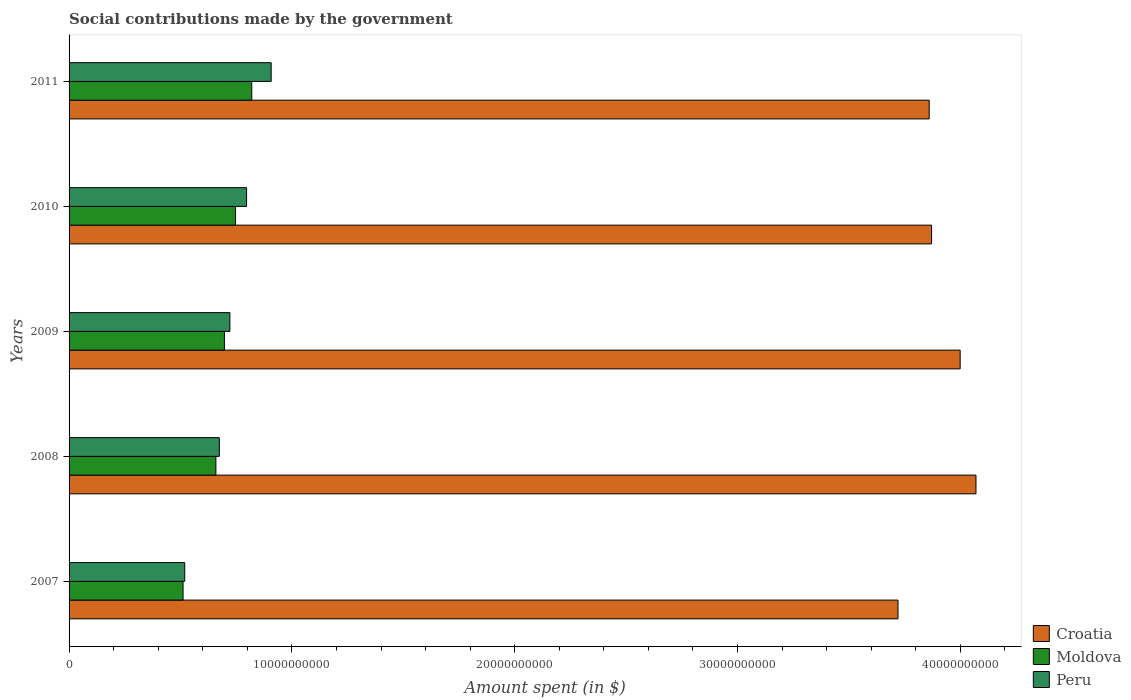How many groups of bars are there?
Make the answer very short. 5. How many bars are there on the 4th tick from the bottom?
Keep it short and to the point. 3. What is the amount spent on social contributions in Peru in 2011?
Make the answer very short. 9.07e+09. Across all years, what is the maximum amount spent on social contributions in Croatia?
Ensure brevity in your answer.  4.07e+1. Across all years, what is the minimum amount spent on social contributions in Moldova?
Your answer should be compact. 5.12e+09. In which year was the amount spent on social contributions in Croatia minimum?
Ensure brevity in your answer.  2007. What is the total amount spent on social contributions in Peru in the graph?
Ensure brevity in your answer.  3.62e+1. What is the difference between the amount spent on social contributions in Moldova in 2009 and that in 2011?
Provide a succinct answer. -1.23e+09. What is the difference between the amount spent on social contributions in Peru in 2009 and the amount spent on social contributions in Moldova in 2011?
Ensure brevity in your answer.  -9.81e+08. What is the average amount spent on social contributions in Croatia per year?
Provide a short and direct response. 3.90e+1. In the year 2007, what is the difference between the amount spent on social contributions in Moldova and amount spent on social contributions in Croatia?
Keep it short and to the point. -3.21e+1. In how many years, is the amount spent on social contributions in Croatia greater than 34000000000 $?
Give a very brief answer. 5. What is the ratio of the amount spent on social contributions in Peru in 2008 to that in 2010?
Offer a very short reply. 0.85. Is the difference between the amount spent on social contributions in Moldova in 2007 and 2010 greater than the difference between the amount spent on social contributions in Croatia in 2007 and 2010?
Ensure brevity in your answer.  No. What is the difference between the highest and the second highest amount spent on social contributions in Moldova?
Your answer should be compact. 7.27e+08. What is the difference between the highest and the lowest amount spent on social contributions in Peru?
Provide a succinct answer. 3.88e+09. Is the sum of the amount spent on social contributions in Peru in 2009 and 2010 greater than the maximum amount spent on social contributions in Moldova across all years?
Keep it short and to the point. Yes. What does the 2nd bar from the bottom in 2010 represents?
Your response must be concise. Moldova. Is it the case that in every year, the sum of the amount spent on social contributions in Croatia and amount spent on social contributions in Moldova is greater than the amount spent on social contributions in Peru?
Provide a short and direct response. Yes. How many bars are there?
Provide a succinct answer. 15. Does the graph contain any zero values?
Make the answer very short. No. How are the legend labels stacked?
Offer a terse response. Vertical. What is the title of the graph?
Keep it short and to the point. Social contributions made by the government. What is the label or title of the X-axis?
Make the answer very short. Amount spent (in $). What is the label or title of the Y-axis?
Offer a very short reply. Years. What is the Amount spent (in $) in Croatia in 2007?
Your answer should be compact. 3.72e+1. What is the Amount spent (in $) of Moldova in 2007?
Your response must be concise. 5.12e+09. What is the Amount spent (in $) of Peru in 2007?
Give a very brief answer. 5.19e+09. What is the Amount spent (in $) of Croatia in 2008?
Make the answer very short. 4.07e+1. What is the Amount spent (in $) of Moldova in 2008?
Keep it short and to the point. 6.59e+09. What is the Amount spent (in $) of Peru in 2008?
Your answer should be compact. 6.74e+09. What is the Amount spent (in $) of Croatia in 2009?
Give a very brief answer. 4.00e+1. What is the Amount spent (in $) of Moldova in 2009?
Provide a succinct answer. 6.97e+09. What is the Amount spent (in $) of Peru in 2009?
Provide a succinct answer. 7.22e+09. What is the Amount spent (in $) in Croatia in 2010?
Your answer should be very brief. 3.87e+1. What is the Amount spent (in $) in Moldova in 2010?
Ensure brevity in your answer.  7.47e+09. What is the Amount spent (in $) of Peru in 2010?
Give a very brief answer. 7.97e+09. What is the Amount spent (in $) of Croatia in 2011?
Make the answer very short. 3.86e+1. What is the Amount spent (in $) of Moldova in 2011?
Make the answer very short. 8.20e+09. What is the Amount spent (in $) of Peru in 2011?
Make the answer very short. 9.07e+09. Across all years, what is the maximum Amount spent (in $) in Croatia?
Your answer should be very brief. 4.07e+1. Across all years, what is the maximum Amount spent (in $) in Moldova?
Ensure brevity in your answer.  8.20e+09. Across all years, what is the maximum Amount spent (in $) in Peru?
Your response must be concise. 9.07e+09. Across all years, what is the minimum Amount spent (in $) of Croatia?
Give a very brief answer. 3.72e+1. Across all years, what is the minimum Amount spent (in $) in Moldova?
Provide a short and direct response. 5.12e+09. Across all years, what is the minimum Amount spent (in $) in Peru?
Give a very brief answer. 5.19e+09. What is the total Amount spent (in $) of Croatia in the graph?
Keep it short and to the point. 1.95e+11. What is the total Amount spent (in $) of Moldova in the graph?
Your response must be concise. 3.43e+1. What is the total Amount spent (in $) in Peru in the graph?
Your response must be concise. 3.62e+1. What is the difference between the Amount spent (in $) of Croatia in 2007 and that in 2008?
Offer a very short reply. -3.50e+09. What is the difference between the Amount spent (in $) of Moldova in 2007 and that in 2008?
Your response must be concise. -1.47e+09. What is the difference between the Amount spent (in $) of Peru in 2007 and that in 2008?
Your response must be concise. -1.55e+09. What is the difference between the Amount spent (in $) in Croatia in 2007 and that in 2009?
Give a very brief answer. -2.79e+09. What is the difference between the Amount spent (in $) in Moldova in 2007 and that in 2009?
Your answer should be very brief. -1.86e+09. What is the difference between the Amount spent (in $) in Peru in 2007 and that in 2009?
Provide a short and direct response. -2.03e+09. What is the difference between the Amount spent (in $) of Croatia in 2007 and that in 2010?
Your answer should be compact. -1.51e+09. What is the difference between the Amount spent (in $) of Moldova in 2007 and that in 2010?
Provide a succinct answer. -2.36e+09. What is the difference between the Amount spent (in $) in Peru in 2007 and that in 2010?
Offer a very short reply. -2.78e+09. What is the difference between the Amount spent (in $) of Croatia in 2007 and that in 2011?
Give a very brief answer. -1.40e+09. What is the difference between the Amount spent (in $) of Moldova in 2007 and that in 2011?
Your answer should be very brief. -3.08e+09. What is the difference between the Amount spent (in $) of Peru in 2007 and that in 2011?
Offer a terse response. -3.88e+09. What is the difference between the Amount spent (in $) of Croatia in 2008 and that in 2009?
Offer a terse response. 7.09e+08. What is the difference between the Amount spent (in $) of Moldova in 2008 and that in 2009?
Make the answer very short. -3.82e+08. What is the difference between the Amount spent (in $) in Peru in 2008 and that in 2009?
Provide a short and direct response. -4.73e+08. What is the difference between the Amount spent (in $) in Croatia in 2008 and that in 2010?
Your answer should be compact. 1.99e+09. What is the difference between the Amount spent (in $) of Moldova in 2008 and that in 2010?
Keep it short and to the point. -8.82e+08. What is the difference between the Amount spent (in $) in Peru in 2008 and that in 2010?
Provide a short and direct response. -1.22e+09. What is the difference between the Amount spent (in $) of Croatia in 2008 and that in 2011?
Ensure brevity in your answer.  2.10e+09. What is the difference between the Amount spent (in $) of Moldova in 2008 and that in 2011?
Offer a very short reply. -1.61e+09. What is the difference between the Amount spent (in $) of Peru in 2008 and that in 2011?
Provide a succinct answer. -2.33e+09. What is the difference between the Amount spent (in $) in Croatia in 2009 and that in 2010?
Provide a short and direct response. 1.28e+09. What is the difference between the Amount spent (in $) in Moldova in 2009 and that in 2010?
Ensure brevity in your answer.  -5.00e+08. What is the difference between the Amount spent (in $) of Peru in 2009 and that in 2010?
Provide a short and direct response. -7.49e+08. What is the difference between the Amount spent (in $) in Croatia in 2009 and that in 2011?
Make the answer very short. 1.39e+09. What is the difference between the Amount spent (in $) of Moldova in 2009 and that in 2011?
Give a very brief answer. -1.23e+09. What is the difference between the Amount spent (in $) of Peru in 2009 and that in 2011?
Your answer should be compact. -1.85e+09. What is the difference between the Amount spent (in $) in Croatia in 2010 and that in 2011?
Ensure brevity in your answer.  1.07e+08. What is the difference between the Amount spent (in $) of Moldova in 2010 and that in 2011?
Provide a short and direct response. -7.27e+08. What is the difference between the Amount spent (in $) of Peru in 2010 and that in 2011?
Your response must be concise. -1.10e+09. What is the difference between the Amount spent (in $) in Croatia in 2007 and the Amount spent (in $) in Moldova in 2008?
Provide a short and direct response. 3.06e+1. What is the difference between the Amount spent (in $) in Croatia in 2007 and the Amount spent (in $) in Peru in 2008?
Offer a very short reply. 3.05e+1. What is the difference between the Amount spent (in $) in Moldova in 2007 and the Amount spent (in $) in Peru in 2008?
Keep it short and to the point. -1.63e+09. What is the difference between the Amount spent (in $) of Croatia in 2007 and the Amount spent (in $) of Moldova in 2009?
Keep it short and to the point. 3.02e+1. What is the difference between the Amount spent (in $) of Croatia in 2007 and the Amount spent (in $) of Peru in 2009?
Give a very brief answer. 3.00e+1. What is the difference between the Amount spent (in $) of Moldova in 2007 and the Amount spent (in $) of Peru in 2009?
Your response must be concise. -2.10e+09. What is the difference between the Amount spent (in $) of Croatia in 2007 and the Amount spent (in $) of Moldova in 2010?
Provide a short and direct response. 2.97e+1. What is the difference between the Amount spent (in $) in Croatia in 2007 and the Amount spent (in $) in Peru in 2010?
Provide a succinct answer. 2.92e+1. What is the difference between the Amount spent (in $) of Moldova in 2007 and the Amount spent (in $) of Peru in 2010?
Your response must be concise. -2.85e+09. What is the difference between the Amount spent (in $) in Croatia in 2007 and the Amount spent (in $) in Moldova in 2011?
Keep it short and to the point. 2.90e+1. What is the difference between the Amount spent (in $) in Croatia in 2007 and the Amount spent (in $) in Peru in 2011?
Provide a short and direct response. 2.81e+1. What is the difference between the Amount spent (in $) of Moldova in 2007 and the Amount spent (in $) of Peru in 2011?
Give a very brief answer. -3.95e+09. What is the difference between the Amount spent (in $) of Croatia in 2008 and the Amount spent (in $) of Moldova in 2009?
Offer a very short reply. 3.37e+1. What is the difference between the Amount spent (in $) of Croatia in 2008 and the Amount spent (in $) of Peru in 2009?
Offer a terse response. 3.35e+1. What is the difference between the Amount spent (in $) of Moldova in 2008 and the Amount spent (in $) of Peru in 2009?
Give a very brief answer. -6.28e+08. What is the difference between the Amount spent (in $) of Croatia in 2008 and the Amount spent (in $) of Moldova in 2010?
Keep it short and to the point. 3.32e+1. What is the difference between the Amount spent (in $) in Croatia in 2008 and the Amount spent (in $) in Peru in 2010?
Offer a very short reply. 3.27e+1. What is the difference between the Amount spent (in $) of Moldova in 2008 and the Amount spent (in $) of Peru in 2010?
Offer a very short reply. -1.38e+09. What is the difference between the Amount spent (in $) in Croatia in 2008 and the Amount spent (in $) in Moldova in 2011?
Provide a short and direct response. 3.25e+1. What is the difference between the Amount spent (in $) in Croatia in 2008 and the Amount spent (in $) in Peru in 2011?
Give a very brief answer. 3.16e+1. What is the difference between the Amount spent (in $) of Moldova in 2008 and the Amount spent (in $) of Peru in 2011?
Ensure brevity in your answer.  -2.48e+09. What is the difference between the Amount spent (in $) in Croatia in 2009 and the Amount spent (in $) in Moldova in 2010?
Offer a very short reply. 3.25e+1. What is the difference between the Amount spent (in $) in Croatia in 2009 and the Amount spent (in $) in Peru in 2010?
Keep it short and to the point. 3.20e+1. What is the difference between the Amount spent (in $) in Moldova in 2009 and the Amount spent (in $) in Peru in 2010?
Your response must be concise. -9.95e+08. What is the difference between the Amount spent (in $) of Croatia in 2009 and the Amount spent (in $) of Moldova in 2011?
Your answer should be compact. 3.18e+1. What is the difference between the Amount spent (in $) in Croatia in 2009 and the Amount spent (in $) in Peru in 2011?
Your answer should be very brief. 3.09e+1. What is the difference between the Amount spent (in $) of Moldova in 2009 and the Amount spent (in $) of Peru in 2011?
Your response must be concise. -2.10e+09. What is the difference between the Amount spent (in $) in Croatia in 2010 and the Amount spent (in $) in Moldova in 2011?
Your answer should be compact. 3.05e+1. What is the difference between the Amount spent (in $) of Croatia in 2010 and the Amount spent (in $) of Peru in 2011?
Keep it short and to the point. 2.96e+1. What is the difference between the Amount spent (in $) in Moldova in 2010 and the Amount spent (in $) in Peru in 2011?
Offer a very short reply. -1.60e+09. What is the average Amount spent (in $) in Croatia per year?
Your answer should be compact. 3.90e+1. What is the average Amount spent (in $) in Moldova per year?
Provide a short and direct response. 6.87e+09. What is the average Amount spent (in $) of Peru per year?
Give a very brief answer. 7.24e+09. In the year 2007, what is the difference between the Amount spent (in $) of Croatia and Amount spent (in $) of Moldova?
Your answer should be very brief. 3.21e+1. In the year 2007, what is the difference between the Amount spent (in $) in Croatia and Amount spent (in $) in Peru?
Give a very brief answer. 3.20e+1. In the year 2007, what is the difference between the Amount spent (in $) of Moldova and Amount spent (in $) of Peru?
Provide a short and direct response. -7.49e+07. In the year 2008, what is the difference between the Amount spent (in $) in Croatia and Amount spent (in $) in Moldova?
Offer a very short reply. 3.41e+1. In the year 2008, what is the difference between the Amount spent (in $) of Croatia and Amount spent (in $) of Peru?
Keep it short and to the point. 3.40e+1. In the year 2008, what is the difference between the Amount spent (in $) in Moldova and Amount spent (in $) in Peru?
Your answer should be compact. -1.54e+08. In the year 2009, what is the difference between the Amount spent (in $) of Croatia and Amount spent (in $) of Moldova?
Ensure brevity in your answer.  3.30e+1. In the year 2009, what is the difference between the Amount spent (in $) of Croatia and Amount spent (in $) of Peru?
Your answer should be very brief. 3.28e+1. In the year 2009, what is the difference between the Amount spent (in $) in Moldova and Amount spent (in $) in Peru?
Ensure brevity in your answer.  -2.46e+08. In the year 2010, what is the difference between the Amount spent (in $) of Croatia and Amount spent (in $) of Moldova?
Make the answer very short. 3.12e+1. In the year 2010, what is the difference between the Amount spent (in $) of Croatia and Amount spent (in $) of Peru?
Your answer should be compact. 3.07e+1. In the year 2010, what is the difference between the Amount spent (in $) of Moldova and Amount spent (in $) of Peru?
Your answer should be compact. -4.95e+08. In the year 2011, what is the difference between the Amount spent (in $) in Croatia and Amount spent (in $) in Moldova?
Your answer should be very brief. 3.04e+1. In the year 2011, what is the difference between the Amount spent (in $) in Croatia and Amount spent (in $) in Peru?
Give a very brief answer. 2.95e+1. In the year 2011, what is the difference between the Amount spent (in $) in Moldova and Amount spent (in $) in Peru?
Offer a very short reply. -8.72e+08. What is the ratio of the Amount spent (in $) of Croatia in 2007 to that in 2008?
Your answer should be very brief. 0.91. What is the ratio of the Amount spent (in $) in Moldova in 2007 to that in 2008?
Provide a short and direct response. 0.78. What is the ratio of the Amount spent (in $) of Peru in 2007 to that in 2008?
Your answer should be very brief. 0.77. What is the ratio of the Amount spent (in $) of Croatia in 2007 to that in 2009?
Keep it short and to the point. 0.93. What is the ratio of the Amount spent (in $) in Moldova in 2007 to that in 2009?
Ensure brevity in your answer.  0.73. What is the ratio of the Amount spent (in $) of Peru in 2007 to that in 2009?
Make the answer very short. 0.72. What is the ratio of the Amount spent (in $) of Moldova in 2007 to that in 2010?
Your answer should be compact. 0.68. What is the ratio of the Amount spent (in $) in Peru in 2007 to that in 2010?
Give a very brief answer. 0.65. What is the ratio of the Amount spent (in $) of Croatia in 2007 to that in 2011?
Keep it short and to the point. 0.96. What is the ratio of the Amount spent (in $) of Moldova in 2007 to that in 2011?
Provide a short and direct response. 0.62. What is the ratio of the Amount spent (in $) of Peru in 2007 to that in 2011?
Make the answer very short. 0.57. What is the ratio of the Amount spent (in $) in Croatia in 2008 to that in 2009?
Provide a short and direct response. 1.02. What is the ratio of the Amount spent (in $) in Moldova in 2008 to that in 2009?
Keep it short and to the point. 0.95. What is the ratio of the Amount spent (in $) in Peru in 2008 to that in 2009?
Ensure brevity in your answer.  0.93. What is the ratio of the Amount spent (in $) in Croatia in 2008 to that in 2010?
Give a very brief answer. 1.05. What is the ratio of the Amount spent (in $) in Moldova in 2008 to that in 2010?
Your answer should be very brief. 0.88. What is the ratio of the Amount spent (in $) in Peru in 2008 to that in 2010?
Provide a short and direct response. 0.85. What is the ratio of the Amount spent (in $) of Croatia in 2008 to that in 2011?
Ensure brevity in your answer.  1.05. What is the ratio of the Amount spent (in $) in Moldova in 2008 to that in 2011?
Make the answer very short. 0.8. What is the ratio of the Amount spent (in $) of Peru in 2008 to that in 2011?
Provide a short and direct response. 0.74. What is the ratio of the Amount spent (in $) in Croatia in 2009 to that in 2010?
Provide a short and direct response. 1.03. What is the ratio of the Amount spent (in $) in Moldova in 2009 to that in 2010?
Your response must be concise. 0.93. What is the ratio of the Amount spent (in $) in Peru in 2009 to that in 2010?
Provide a succinct answer. 0.91. What is the ratio of the Amount spent (in $) of Croatia in 2009 to that in 2011?
Make the answer very short. 1.04. What is the ratio of the Amount spent (in $) in Moldova in 2009 to that in 2011?
Your answer should be compact. 0.85. What is the ratio of the Amount spent (in $) in Peru in 2009 to that in 2011?
Offer a terse response. 0.8. What is the ratio of the Amount spent (in $) of Croatia in 2010 to that in 2011?
Give a very brief answer. 1. What is the ratio of the Amount spent (in $) of Moldova in 2010 to that in 2011?
Offer a very short reply. 0.91. What is the ratio of the Amount spent (in $) of Peru in 2010 to that in 2011?
Offer a very short reply. 0.88. What is the difference between the highest and the second highest Amount spent (in $) of Croatia?
Offer a terse response. 7.09e+08. What is the difference between the highest and the second highest Amount spent (in $) in Moldova?
Ensure brevity in your answer.  7.27e+08. What is the difference between the highest and the second highest Amount spent (in $) in Peru?
Make the answer very short. 1.10e+09. What is the difference between the highest and the lowest Amount spent (in $) of Croatia?
Provide a short and direct response. 3.50e+09. What is the difference between the highest and the lowest Amount spent (in $) of Moldova?
Provide a short and direct response. 3.08e+09. What is the difference between the highest and the lowest Amount spent (in $) of Peru?
Your answer should be very brief. 3.88e+09. 